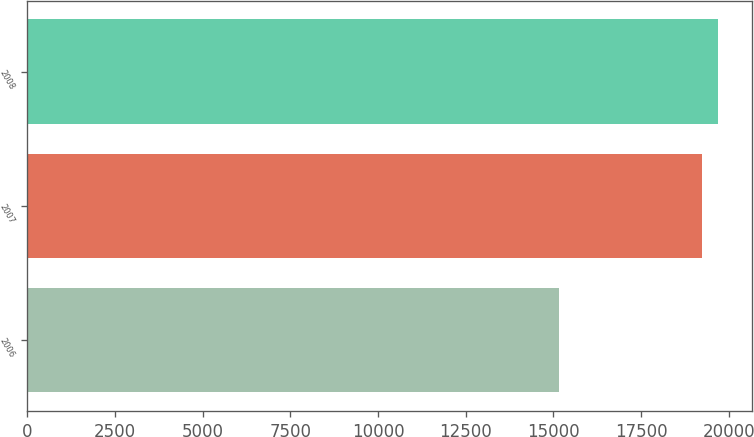Convert chart. <chart><loc_0><loc_0><loc_500><loc_500><bar_chart><fcel>2006<fcel>2007<fcel>2008<nl><fcel>15157<fcel>19246<fcel>19686.5<nl></chart> 